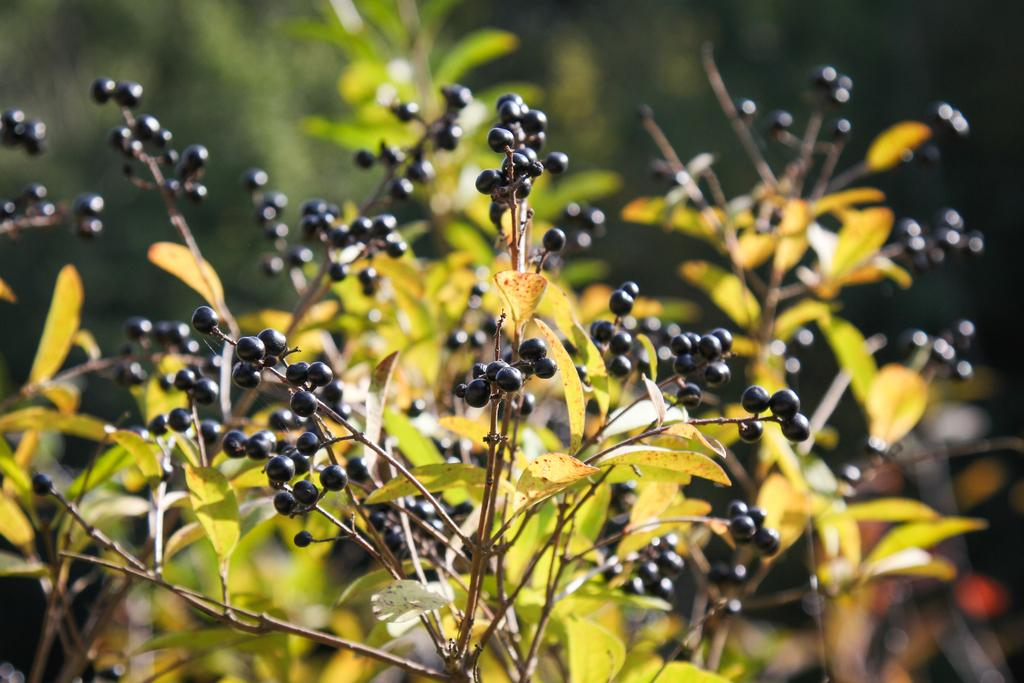What type of food can be seen in the image? There are fruits in the image. What part of the fruit is connected to the branch or stem? The fruits have stems in the image. What part of the fruit is attached to the stem? The fruits have leaves in the image. What type of plot is being investigated by the police in the image? There is no plot or police present in the image; it features fruits with stems and leaves. Can you tell me how many balls are visible in the image? There are no balls present in the image; it features fruits with stems and leaves. 